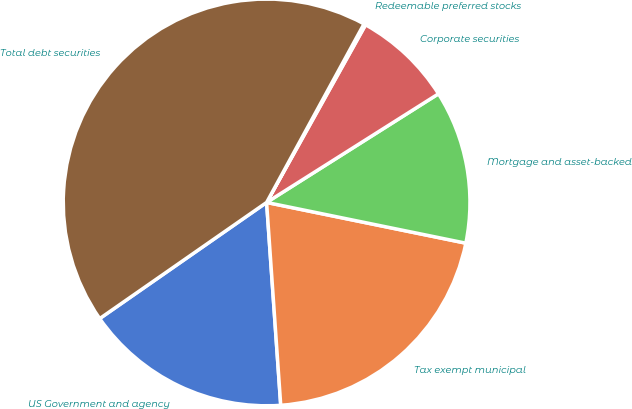<chart> <loc_0><loc_0><loc_500><loc_500><pie_chart><fcel>US Government and agency<fcel>Tax exempt municipal<fcel>Mortgage and asset-backed<fcel>Corporate securities<fcel>Redeemable preferred stocks<fcel>Total debt securities<nl><fcel>16.43%<fcel>20.68%<fcel>12.18%<fcel>7.94%<fcel>0.14%<fcel>42.62%<nl></chart> 